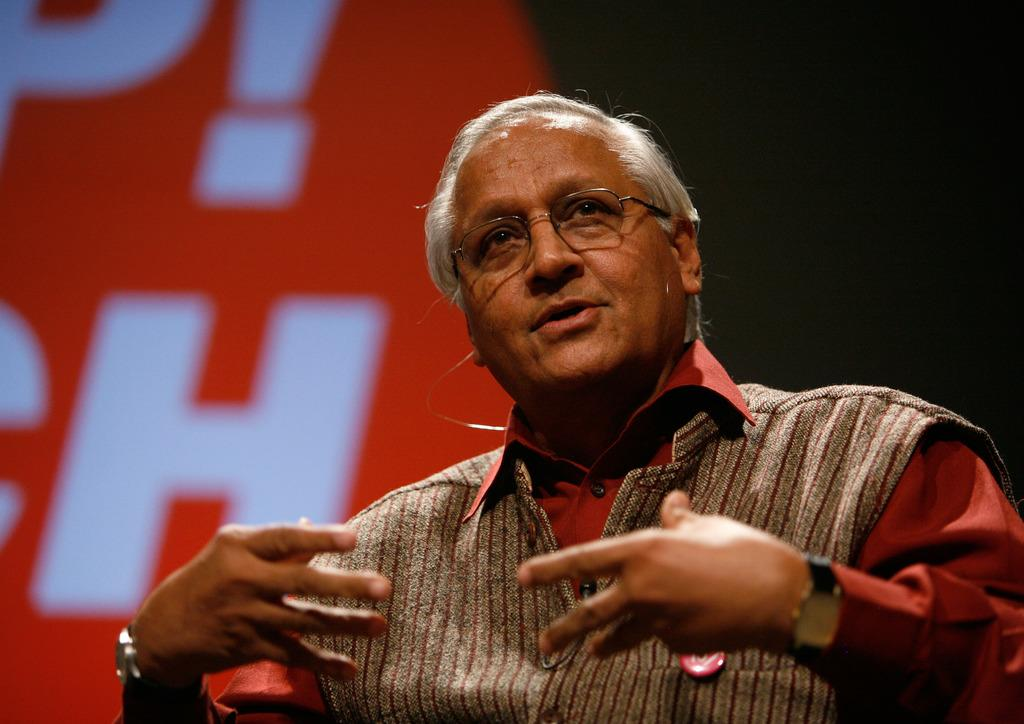What activity is the person in the image engaged in? The person in the image is riding a bicycle. What can be seen in the background of the image? There is a tree in the background of the image. What hour is the achiever mentioned in the image? There is no mention of an achiever or any specific hour in the image. 